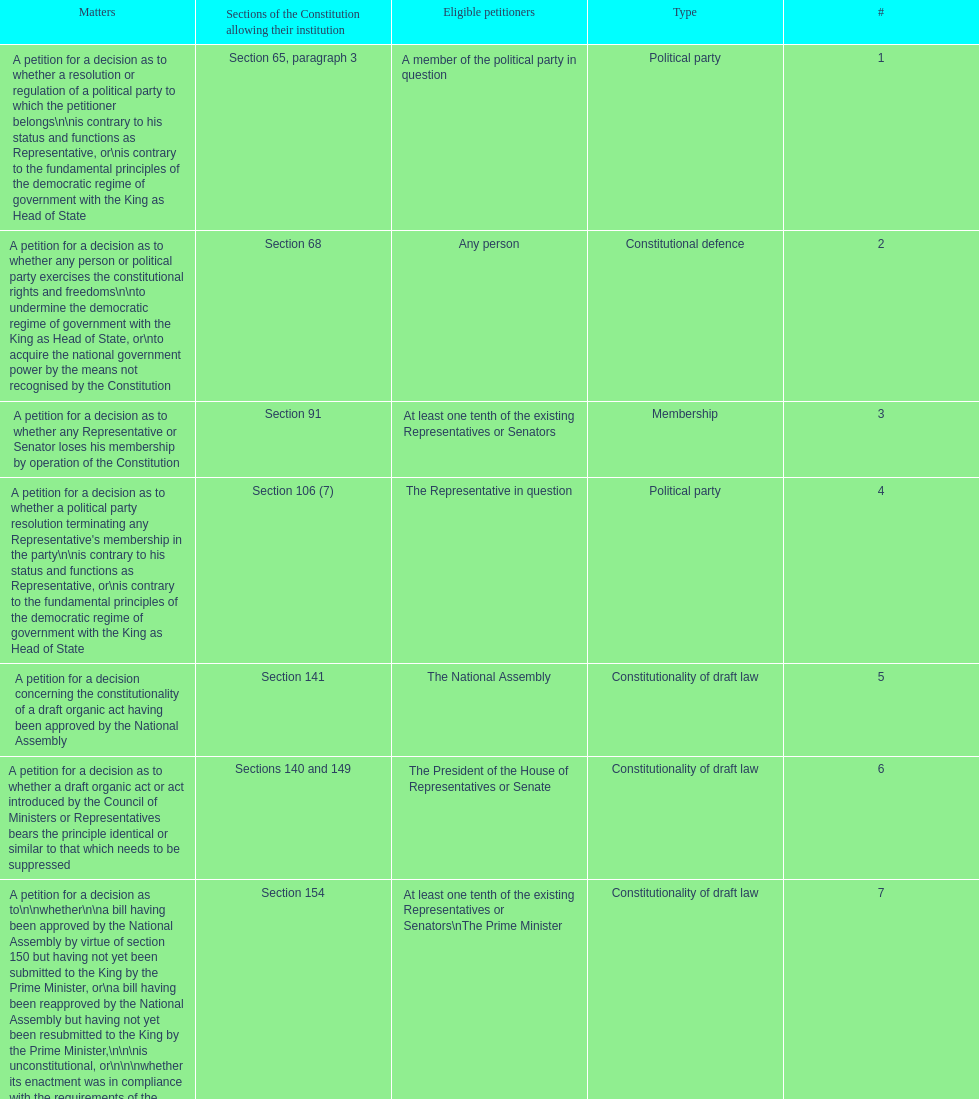Any person can petition matters 2 and 17. true or false? True. 